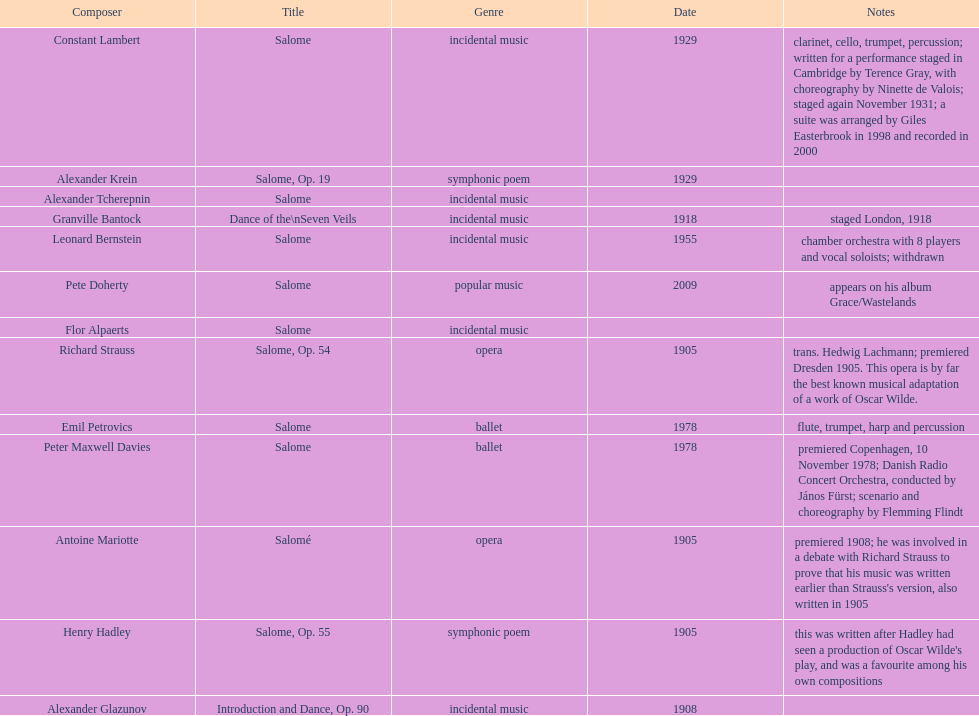What work was written after henry hadley had seen an oscar wilde play? Salome, Op. 55. 